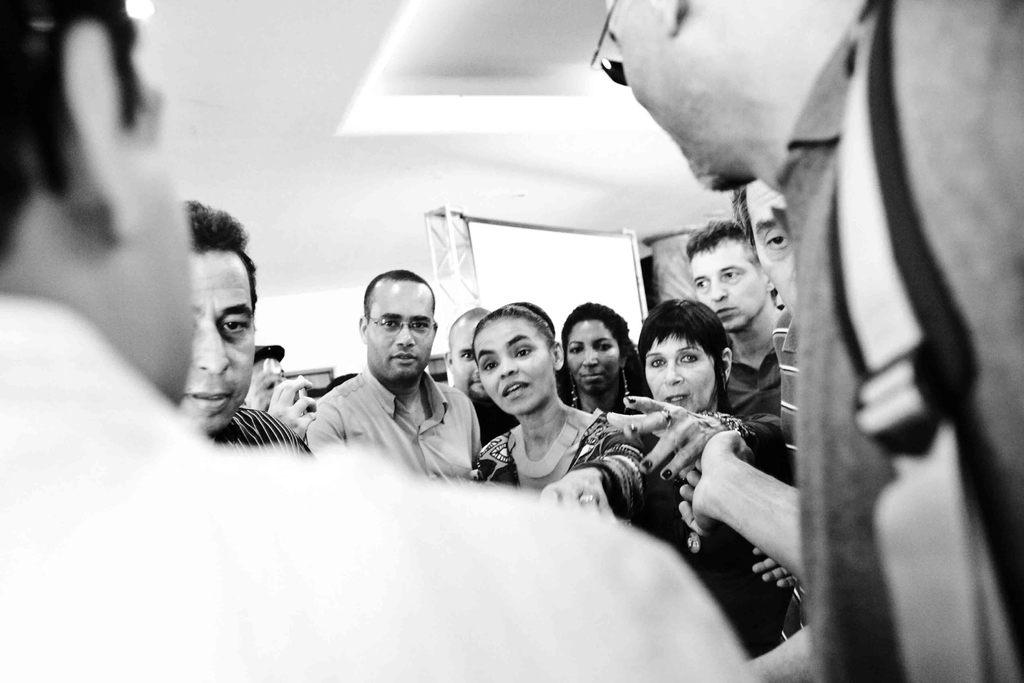What is the color scheme of the image? The image is black and white. How many people are in the image? There are multiple people in the image. Can you describe the gender of some of the people in the image? Some of the people are women, and some are men. What type of leaf is being burned by the creator in the image? There is no leaf or creator present in the image; it only features multiple people in a black and white setting. 